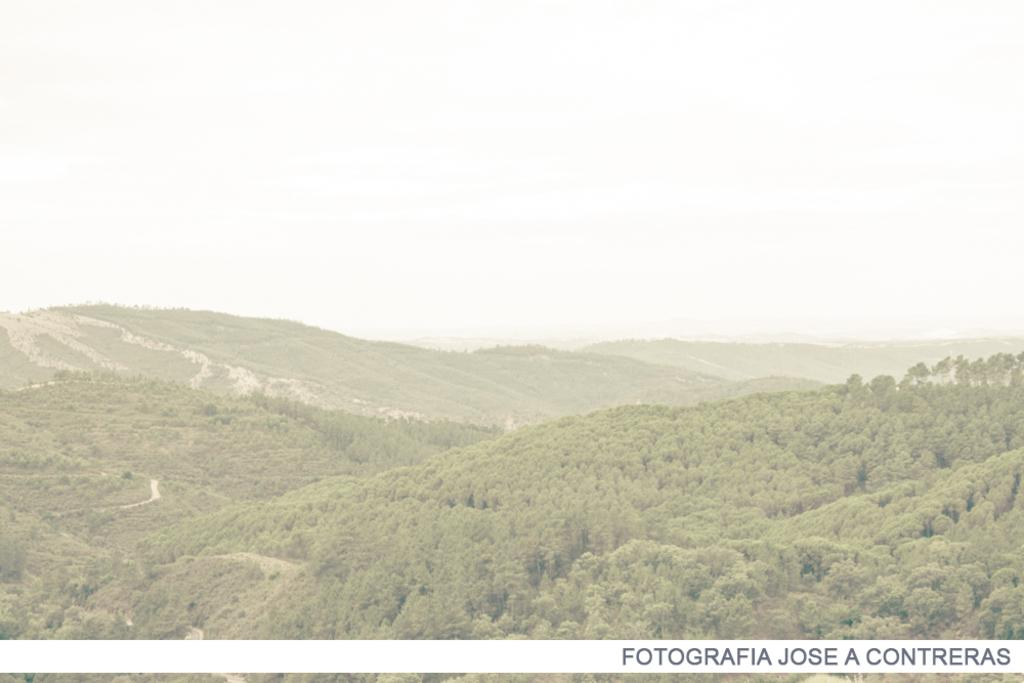What type of landscape can be seen in the image? There are hills in the image. What else is visible in the image besides the hills? The sky is visible in the image. How many robins are perched on the plate in the image? There are no robins or plates present in the image. 